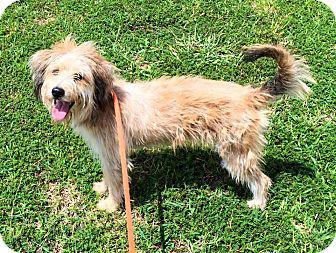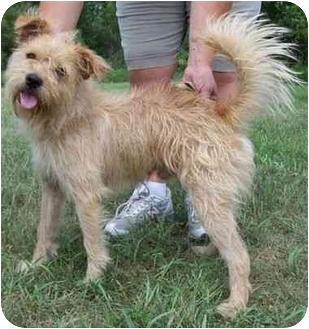The first image is the image on the left, the second image is the image on the right. Given the left and right images, does the statement "An image contains a small dog with water in the background." hold true? Answer yes or no. No. The first image is the image on the left, the second image is the image on the right. Examine the images to the left and right. Is the description "At least one image shows a body of water behind one dog." accurate? Answer yes or no. No. 